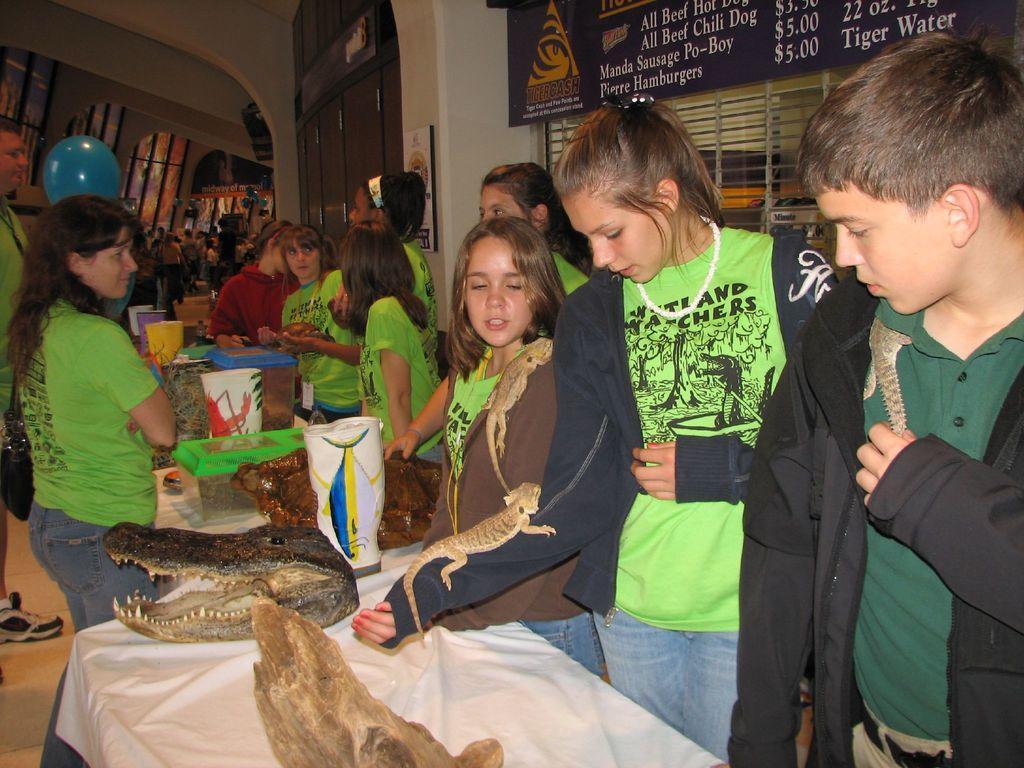How would you summarize this image in a sentence or two? In the center of the image we can see a few people are standing around the table and they are in different costumes. And we can see a few people are holding reptiles. On the table, we can see one cloth, plastic boxes, one crocodile face and a few other objects. In the background there is a wall, fence, banners, few people are standing and a few other objects. On the banners, we can see some text. 